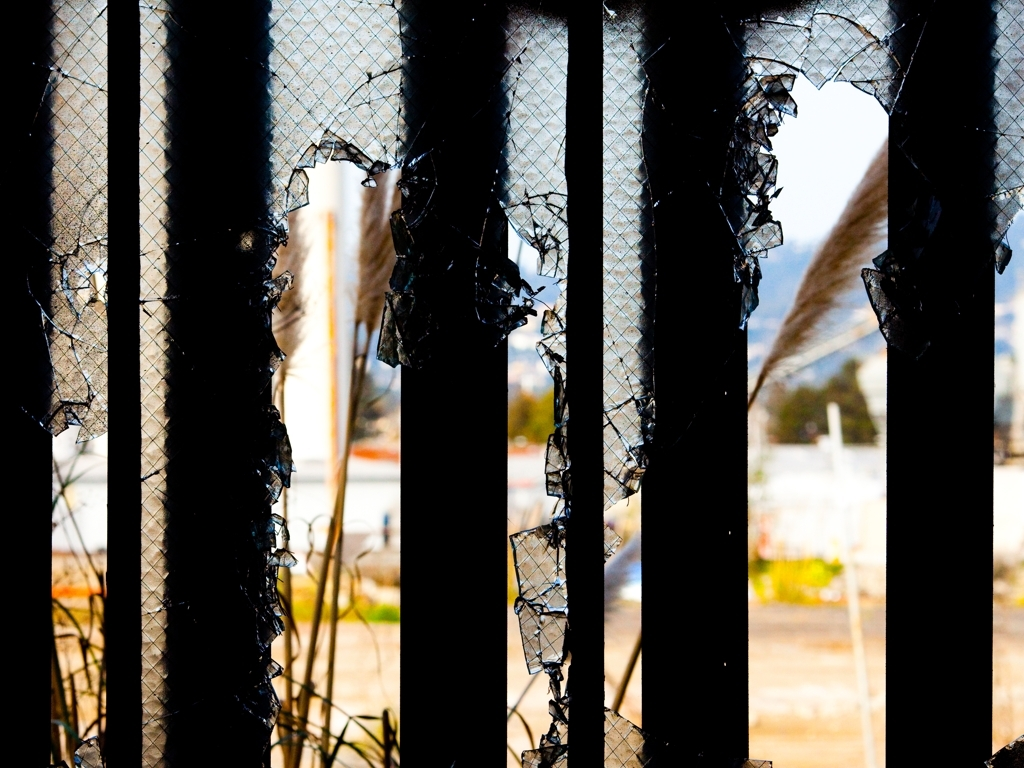Is the image of low quality? The image is of a professional quality in terms of resolution and clarity but features a damaged barrier which may give the mistaken impression of a low-quality image. The focus and composition are purposeful, conveying a specific scene of urban decay or neglect. 